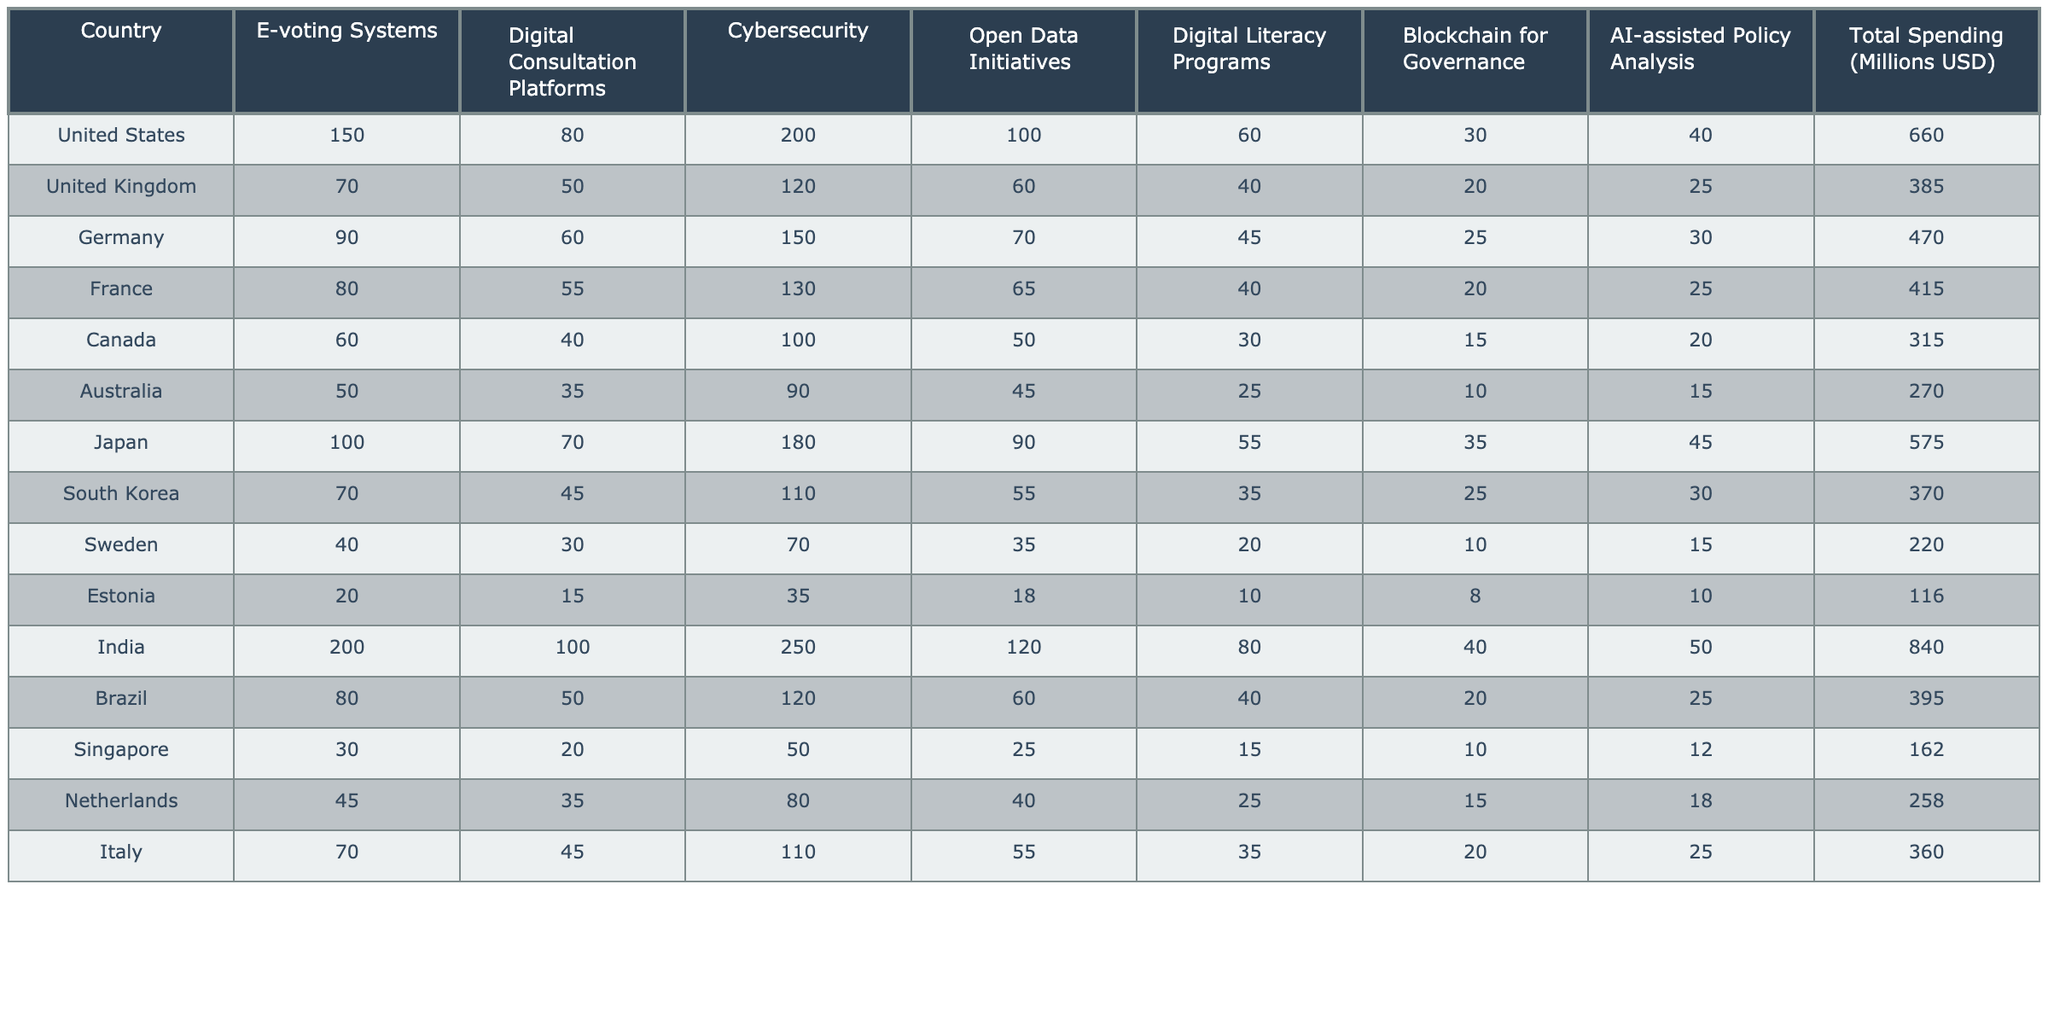What is the total spending on digital democracy initiatives in Japan? The table indicates that the total spending in Japan is 575 million USD.
Answer: 575 million USD Which country spent the most on digital democracy initiatives? India has the highest total spending of 840 million USD on digital democracy initiatives, more than any other country listed.
Answer: India How much did Canada spend on digital literacy programs? According to the table, Canada spent 30 million USD on digital literacy programs.
Answer: 30 million USD What is the total spending by the United Kingdom and Germany combined? The total spending for the United Kingdom is 385 million USD and for Germany is 470 million USD. Adding these values gives: 385 + 470 = 855 million USD.
Answer: 855 million USD Is the spending on cybersecurity in France higher than in the United Kingdom? France's spending on cybersecurity is 130 million USD, while the United Kingdom spent 120 million USD. Since 130 is greater than 120, the statement is true.
Answer: Yes What percentage of India's total spending is allocated to e-voting systems? India's total spending is 840 million USD, and 200 million USD is allocated to e-voting systems. To find the percentage: (200 / 840) * 100 = 23.81%.
Answer: 23.81% Compare the total spending of Australia and Sweden. Which country has a higher total spending, and by how much? Australia spent 270 million USD, while Sweden spent 220 million USD. The difference is 270 - 220 = 50 million USD, so Australia has higher spending by 50 million USD.
Answer: Australia, by 50 million USD What is the average spending on digital consultation platforms across all countries? The total spending on digital consultation platforms can be calculated by adding all the values from that column: 80 + 50 + 60 + 55 + 40 + 35 + 70 + 45 + 30 + 15 + 100 + 50 + 20 + 35 + 45 = 810 million USD. There are 15 countries, so the average is 810 / 15 = 54 million USD.
Answer: 54 million USD Examine the spending on open data initiatives; how many countries spent more than 60 million USD? The countries that spent more than 60 million USD on open data initiatives are the United States (100), Germany (70), France (65), and India (120). Counting these, there are 4 countries.
Answer: 4 countries What conclusion can be drawn about the relationship between digital literacy programs and total spending in the data? Observing the data, there is no clear linear relationship; some countries with high total spending, like India and Japan, also had substantial investments in digital literacy, while others spent less. Thus, a simple correlation is not evident.
Answer: No clear relationship 